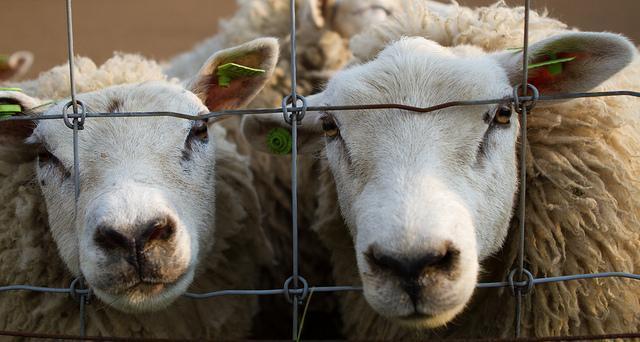How many sheep are there?
Give a very brief answer. 3. How many giraffes are there standing in the sun?
Give a very brief answer. 0. 